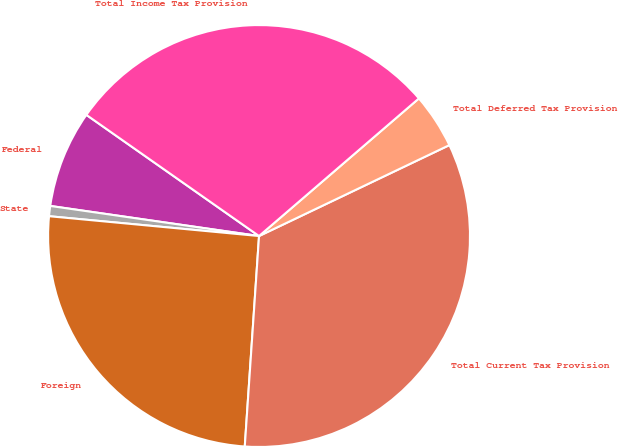<chart> <loc_0><loc_0><loc_500><loc_500><pie_chart><fcel>Federal<fcel>State<fcel>Foreign<fcel>Total Current Tax Provision<fcel>Total Deferred Tax Provision<fcel>Total Income Tax Provision<nl><fcel>7.46%<fcel>0.78%<fcel>25.42%<fcel>33.17%<fcel>4.22%<fcel>28.95%<nl></chart> 